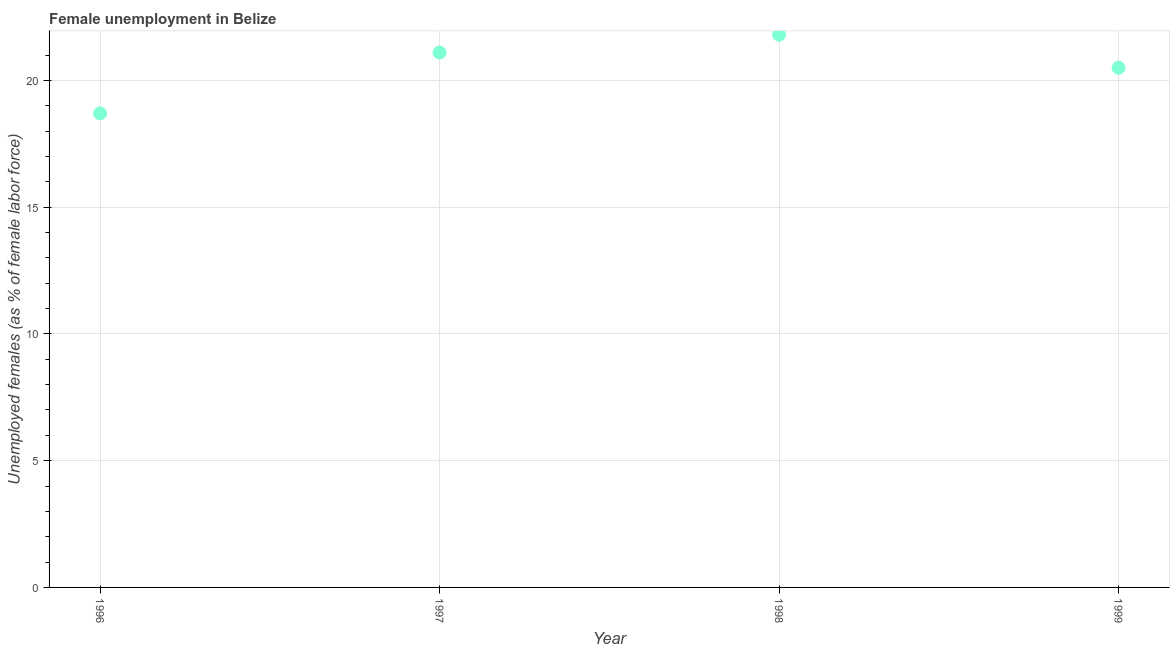What is the unemployed females population in 1998?
Your answer should be compact. 21.8. Across all years, what is the maximum unemployed females population?
Offer a very short reply. 21.8. Across all years, what is the minimum unemployed females population?
Your answer should be very brief. 18.7. In which year was the unemployed females population maximum?
Provide a succinct answer. 1998. In which year was the unemployed females population minimum?
Your answer should be compact. 1996. What is the sum of the unemployed females population?
Make the answer very short. 82.1. What is the difference between the unemployed females population in 1997 and 1998?
Your answer should be compact. -0.7. What is the average unemployed females population per year?
Offer a very short reply. 20.53. What is the median unemployed females population?
Offer a very short reply. 20.8. In how many years, is the unemployed females population greater than 18 %?
Ensure brevity in your answer.  4. What is the ratio of the unemployed females population in 1997 to that in 1999?
Give a very brief answer. 1.03. Is the unemployed females population in 1997 less than that in 1998?
Your response must be concise. Yes. Is the difference between the unemployed females population in 1998 and 1999 greater than the difference between any two years?
Offer a very short reply. No. What is the difference between the highest and the second highest unemployed females population?
Your response must be concise. 0.7. Is the sum of the unemployed females population in 1997 and 1999 greater than the maximum unemployed females population across all years?
Provide a succinct answer. Yes. What is the difference between the highest and the lowest unemployed females population?
Offer a very short reply. 3.1. In how many years, is the unemployed females population greater than the average unemployed females population taken over all years?
Your response must be concise. 2. Does the unemployed females population monotonically increase over the years?
Provide a short and direct response. No. What is the difference between two consecutive major ticks on the Y-axis?
Make the answer very short. 5. Does the graph contain any zero values?
Offer a terse response. No. What is the title of the graph?
Your answer should be very brief. Female unemployment in Belize. What is the label or title of the X-axis?
Offer a terse response. Year. What is the label or title of the Y-axis?
Provide a short and direct response. Unemployed females (as % of female labor force). What is the Unemployed females (as % of female labor force) in 1996?
Offer a terse response. 18.7. What is the Unemployed females (as % of female labor force) in 1997?
Offer a very short reply. 21.1. What is the Unemployed females (as % of female labor force) in 1998?
Provide a short and direct response. 21.8. What is the difference between the Unemployed females (as % of female labor force) in 1996 and 1998?
Offer a terse response. -3.1. What is the difference between the Unemployed females (as % of female labor force) in 1997 and 1998?
Make the answer very short. -0.7. What is the difference between the Unemployed females (as % of female labor force) in 1997 and 1999?
Ensure brevity in your answer.  0.6. What is the ratio of the Unemployed females (as % of female labor force) in 1996 to that in 1997?
Your answer should be compact. 0.89. What is the ratio of the Unemployed females (as % of female labor force) in 1996 to that in 1998?
Your answer should be very brief. 0.86. What is the ratio of the Unemployed females (as % of female labor force) in 1996 to that in 1999?
Provide a short and direct response. 0.91. What is the ratio of the Unemployed females (as % of female labor force) in 1998 to that in 1999?
Give a very brief answer. 1.06. 